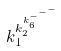Convert formula to latex. <formula><loc_0><loc_0><loc_500><loc_500>k _ { 1 } ^ { k _ { 2 } ^ { k _ { 6 } ^ { - ^ { - ^ { - } } } } }</formula> 